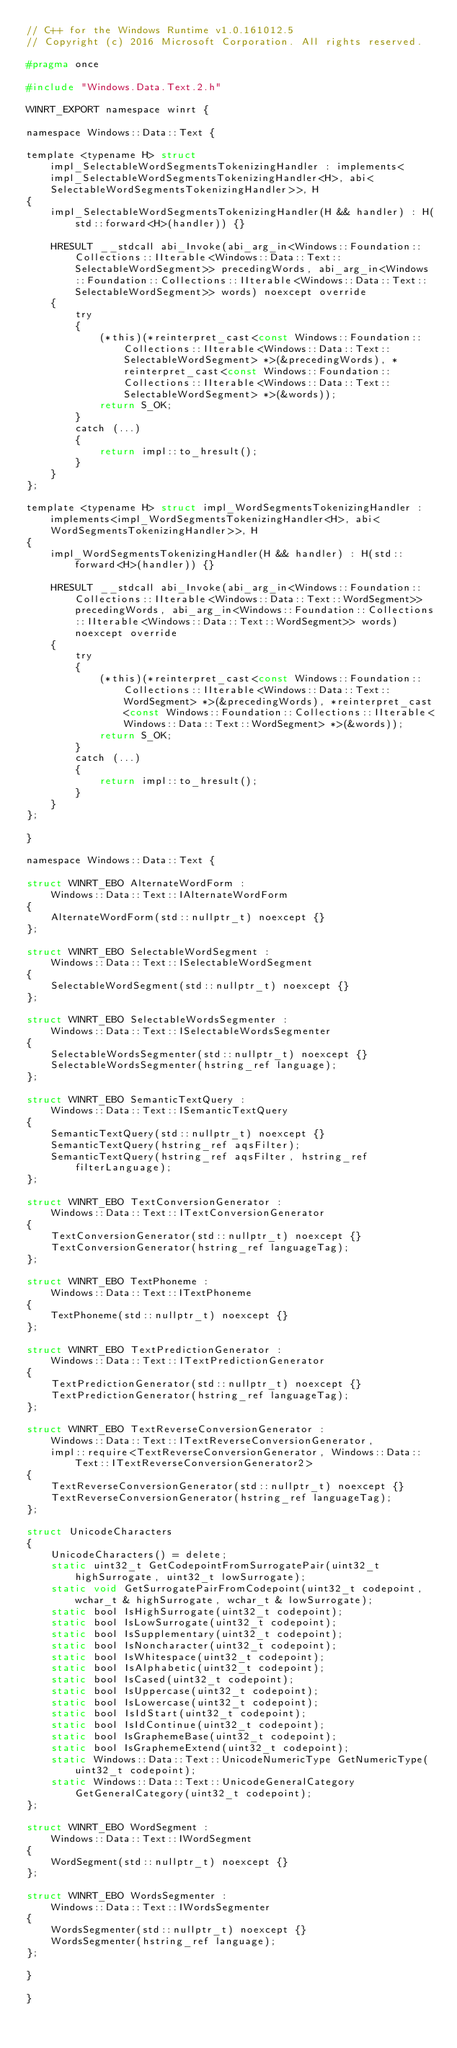<code> <loc_0><loc_0><loc_500><loc_500><_C_>// C++ for the Windows Runtime v1.0.161012.5
// Copyright (c) 2016 Microsoft Corporation. All rights reserved.

#pragma once

#include "Windows.Data.Text.2.h"

WINRT_EXPORT namespace winrt {

namespace Windows::Data::Text {

template <typename H> struct impl_SelectableWordSegmentsTokenizingHandler : implements<impl_SelectableWordSegmentsTokenizingHandler<H>, abi<SelectableWordSegmentsTokenizingHandler>>, H
{
    impl_SelectableWordSegmentsTokenizingHandler(H && handler) : H(std::forward<H>(handler)) {}

    HRESULT __stdcall abi_Invoke(abi_arg_in<Windows::Foundation::Collections::IIterable<Windows::Data::Text::SelectableWordSegment>> precedingWords, abi_arg_in<Windows::Foundation::Collections::IIterable<Windows::Data::Text::SelectableWordSegment>> words) noexcept override
    {
        try
        {
            (*this)(*reinterpret_cast<const Windows::Foundation::Collections::IIterable<Windows::Data::Text::SelectableWordSegment> *>(&precedingWords), *reinterpret_cast<const Windows::Foundation::Collections::IIterable<Windows::Data::Text::SelectableWordSegment> *>(&words));
            return S_OK;
        }
        catch (...)
        {
            return impl::to_hresult();
        }
    }
};

template <typename H> struct impl_WordSegmentsTokenizingHandler : implements<impl_WordSegmentsTokenizingHandler<H>, abi<WordSegmentsTokenizingHandler>>, H
{
    impl_WordSegmentsTokenizingHandler(H && handler) : H(std::forward<H>(handler)) {}

    HRESULT __stdcall abi_Invoke(abi_arg_in<Windows::Foundation::Collections::IIterable<Windows::Data::Text::WordSegment>> precedingWords, abi_arg_in<Windows::Foundation::Collections::IIterable<Windows::Data::Text::WordSegment>> words) noexcept override
    {
        try
        {
            (*this)(*reinterpret_cast<const Windows::Foundation::Collections::IIterable<Windows::Data::Text::WordSegment> *>(&precedingWords), *reinterpret_cast<const Windows::Foundation::Collections::IIterable<Windows::Data::Text::WordSegment> *>(&words));
            return S_OK;
        }
        catch (...)
        {
            return impl::to_hresult();
        }
    }
};

}

namespace Windows::Data::Text {

struct WINRT_EBO AlternateWordForm :
    Windows::Data::Text::IAlternateWordForm
{
    AlternateWordForm(std::nullptr_t) noexcept {}
};

struct WINRT_EBO SelectableWordSegment :
    Windows::Data::Text::ISelectableWordSegment
{
    SelectableWordSegment(std::nullptr_t) noexcept {}
};

struct WINRT_EBO SelectableWordsSegmenter :
    Windows::Data::Text::ISelectableWordsSegmenter
{
    SelectableWordsSegmenter(std::nullptr_t) noexcept {}
    SelectableWordsSegmenter(hstring_ref language);
};

struct WINRT_EBO SemanticTextQuery :
    Windows::Data::Text::ISemanticTextQuery
{
    SemanticTextQuery(std::nullptr_t) noexcept {}
    SemanticTextQuery(hstring_ref aqsFilter);
    SemanticTextQuery(hstring_ref aqsFilter, hstring_ref filterLanguage);
};

struct WINRT_EBO TextConversionGenerator :
    Windows::Data::Text::ITextConversionGenerator
{
    TextConversionGenerator(std::nullptr_t) noexcept {}
    TextConversionGenerator(hstring_ref languageTag);
};

struct WINRT_EBO TextPhoneme :
    Windows::Data::Text::ITextPhoneme
{
    TextPhoneme(std::nullptr_t) noexcept {}
};

struct WINRT_EBO TextPredictionGenerator :
    Windows::Data::Text::ITextPredictionGenerator
{
    TextPredictionGenerator(std::nullptr_t) noexcept {}
    TextPredictionGenerator(hstring_ref languageTag);
};

struct WINRT_EBO TextReverseConversionGenerator :
    Windows::Data::Text::ITextReverseConversionGenerator,
    impl::require<TextReverseConversionGenerator, Windows::Data::Text::ITextReverseConversionGenerator2>
{
    TextReverseConversionGenerator(std::nullptr_t) noexcept {}
    TextReverseConversionGenerator(hstring_ref languageTag);
};

struct UnicodeCharacters
{
    UnicodeCharacters() = delete;
    static uint32_t GetCodepointFromSurrogatePair(uint32_t highSurrogate, uint32_t lowSurrogate);
    static void GetSurrogatePairFromCodepoint(uint32_t codepoint, wchar_t & highSurrogate, wchar_t & lowSurrogate);
    static bool IsHighSurrogate(uint32_t codepoint);
    static bool IsLowSurrogate(uint32_t codepoint);
    static bool IsSupplementary(uint32_t codepoint);
    static bool IsNoncharacter(uint32_t codepoint);
    static bool IsWhitespace(uint32_t codepoint);
    static bool IsAlphabetic(uint32_t codepoint);
    static bool IsCased(uint32_t codepoint);
    static bool IsUppercase(uint32_t codepoint);
    static bool IsLowercase(uint32_t codepoint);
    static bool IsIdStart(uint32_t codepoint);
    static bool IsIdContinue(uint32_t codepoint);
    static bool IsGraphemeBase(uint32_t codepoint);
    static bool IsGraphemeExtend(uint32_t codepoint);
    static Windows::Data::Text::UnicodeNumericType GetNumericType(uint32_t codepoint);
    static Windows::Data::Text::UnicodeGeneralCategory GetGeneralCategory(uint32_t codepoint);
};

struct WINRT_EBO WordSegment :
    Windows::Data::Text::IWordSegment
{
    WordSegment(std::nullptr_t) noexcept {}
};

struct WINRT_EBO WordsSegmenter :
    Windows::Data::Text::IWordsSegmenter
{
    WordsSegmenter(std::nullptr_t) noexcept {}
    WordsSegmenter(hstring_ref language);
};

}

}
</code> 